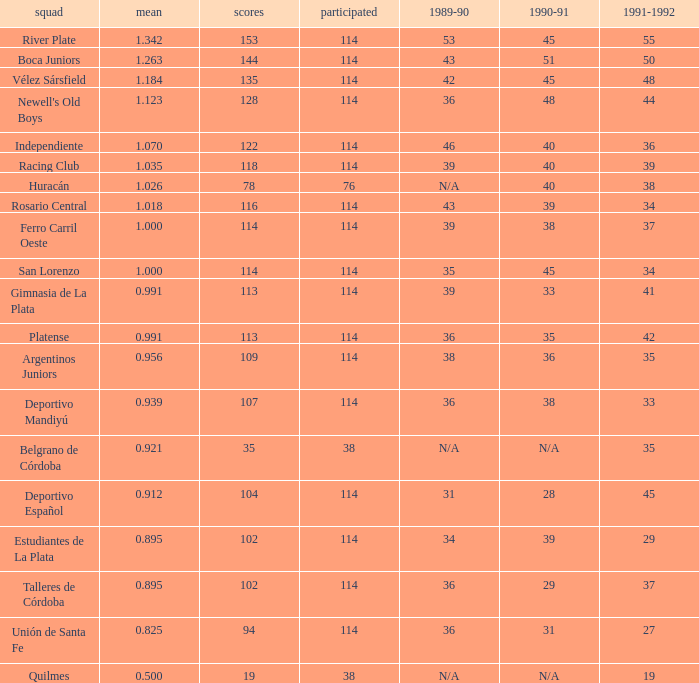How much 1991-1992 has a 1989-90 of 36, and an Average of 0.8250000000000001? 0.0. 